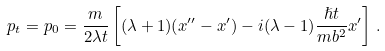Convert formula to latex. <formula><loc_0><loc_0><loc_500><loc_500>p _ { t } = p _ { 0 } = \frac { m } { 2 \lambda t } \left [ ( \lambda + 1 ) ( x ^ { \prime \prime } - x ^ { \prime } ) - i ( \lambda - 1 ) \frac { \hslash t } { m b ^ { 2 } } x ^ { \prime } \right ] \, .</formula> 